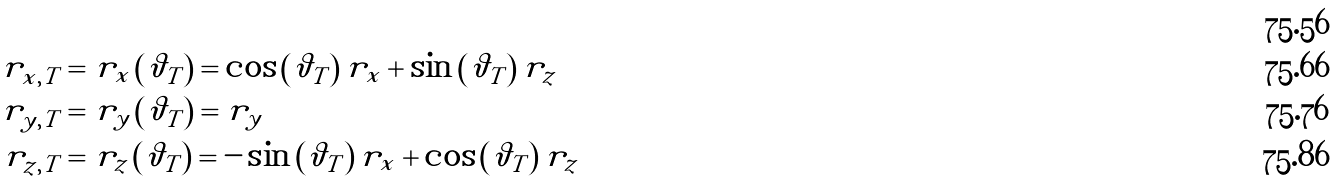<formula> <loc_0><loc_0><loc_500><loc_500>& \\ r _ { x , T } & = r _ { x } \left ( \vartheta _ { T } \right ) = \cos \left ( \vartheta _ { T } \right ) r _ { x } + \sin \left ( \vartheta _ { T } \right ) r _ { z } \\ r _ { y , T } & = r _ { y } \left ( \vartheta _ { T } \right ) = r _ { y } \\ r _ { z , T } & = r _ { z } \left ( \vartheta _ { T } \right ) = - \sin \left ( \vartheta _ { T } \right ) r _ { x } + \cos \left ( \vartheta _ { T } \right ) r _ { z }</formula> 